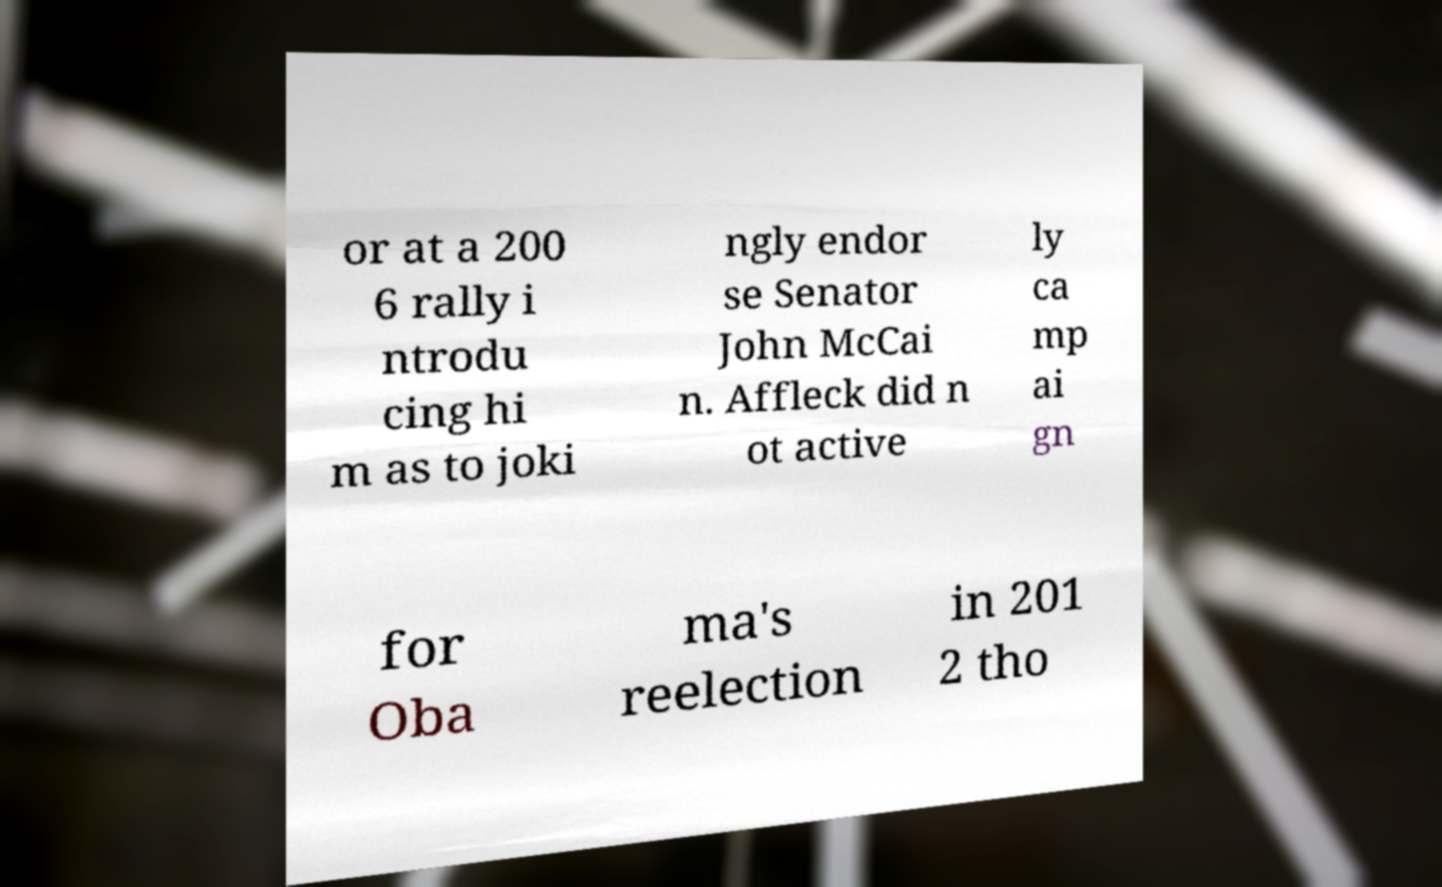There's text embedded in this image that I need extracted. Can you transcribe it verbatim? or at a 200 6 rally i ntrodu cing hi m as to joki ngly endor se Senator John McCai n. Affleck did n ot active ly ca mp ai gn for Oba ma's reelection in 201 2 tho 